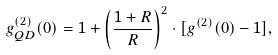<formula> <loc_0><loc_0><loc_500><loc_500>g ^ { ( 2 ) } _ { Q D } ( 0 ) = 1 + \left ( \frac { 1 + R } { R } \right ) ^ { 2 } \cdot [ g ^ { ( 2 ) } ( 0 ) - 1 ] ,</formula> 